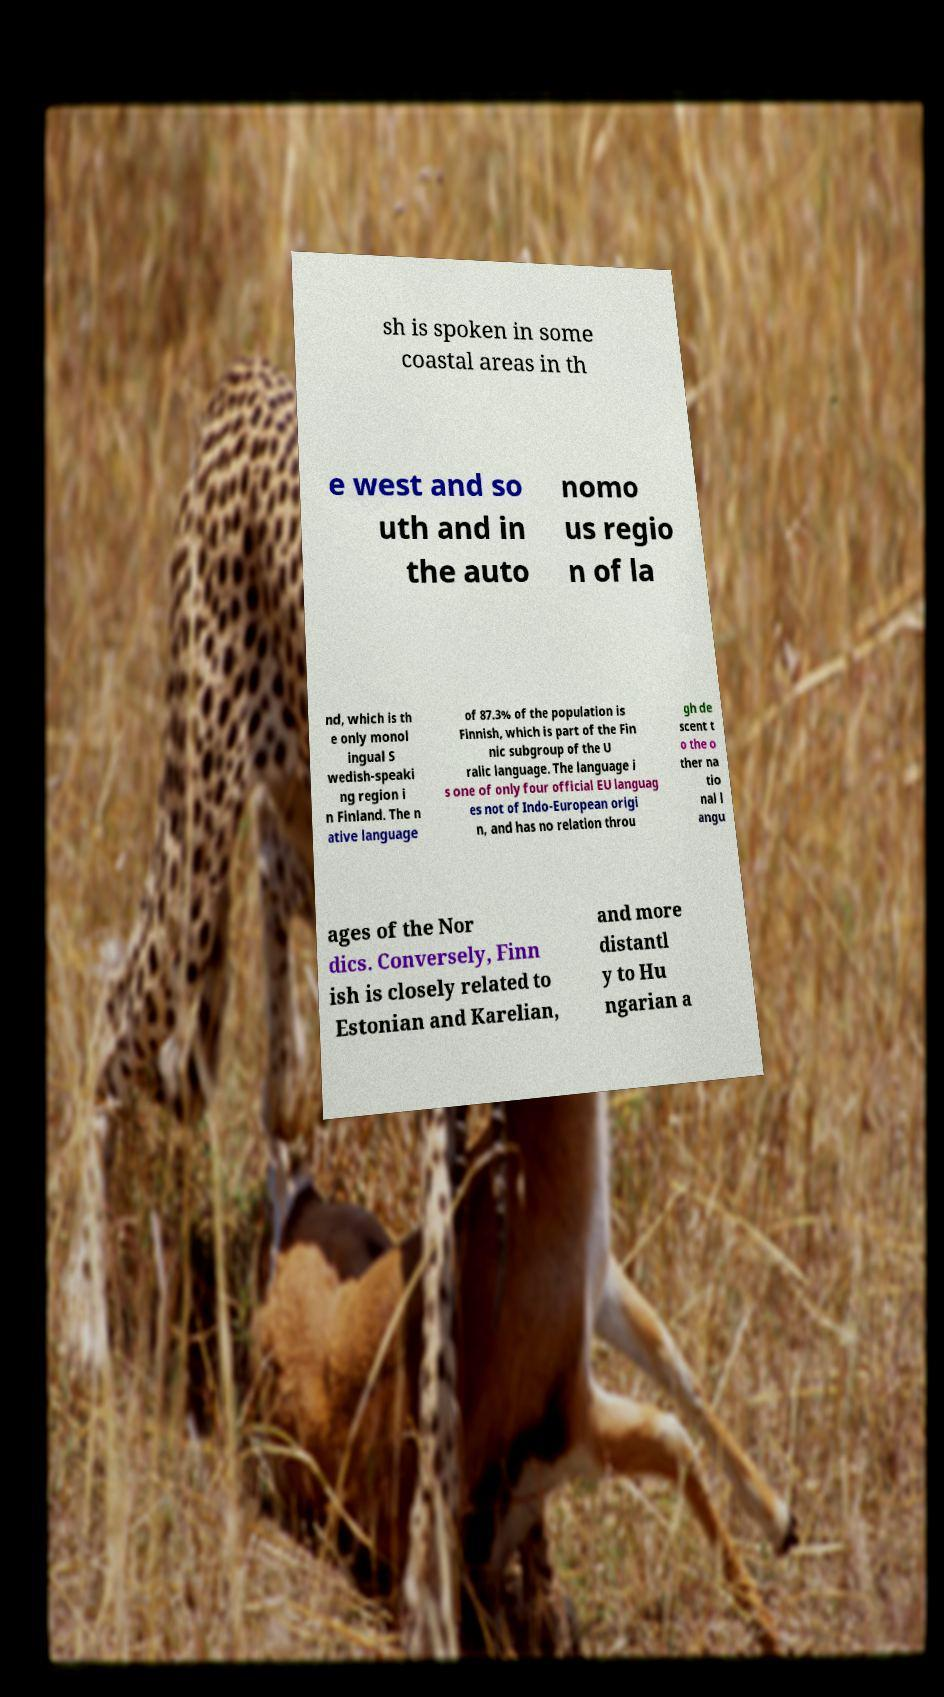Can you read and provide the text displayed in the image?This photo seems to have some interesting text. Can you extract and type it out for me? sh is spoken in some coastal areas in th e west and so uth and in the auto nomo us regio n of la nd, which is th e only monol ingual S wedish-speaki ng region i n Finland. The n ative language of 87.3% of the population is Finnish, which is part of the Fin nic subgroup of the U ralic language. The language i s one of only four official EU languag es not of Indo-European origi n, and has no relation throu gh de scent t o the o ther na tio nal l angu ages of the Nor dics. Conversely, Finn ish is closely related to Estonian and Karelian, and more distantl y to Hu ngarian a 